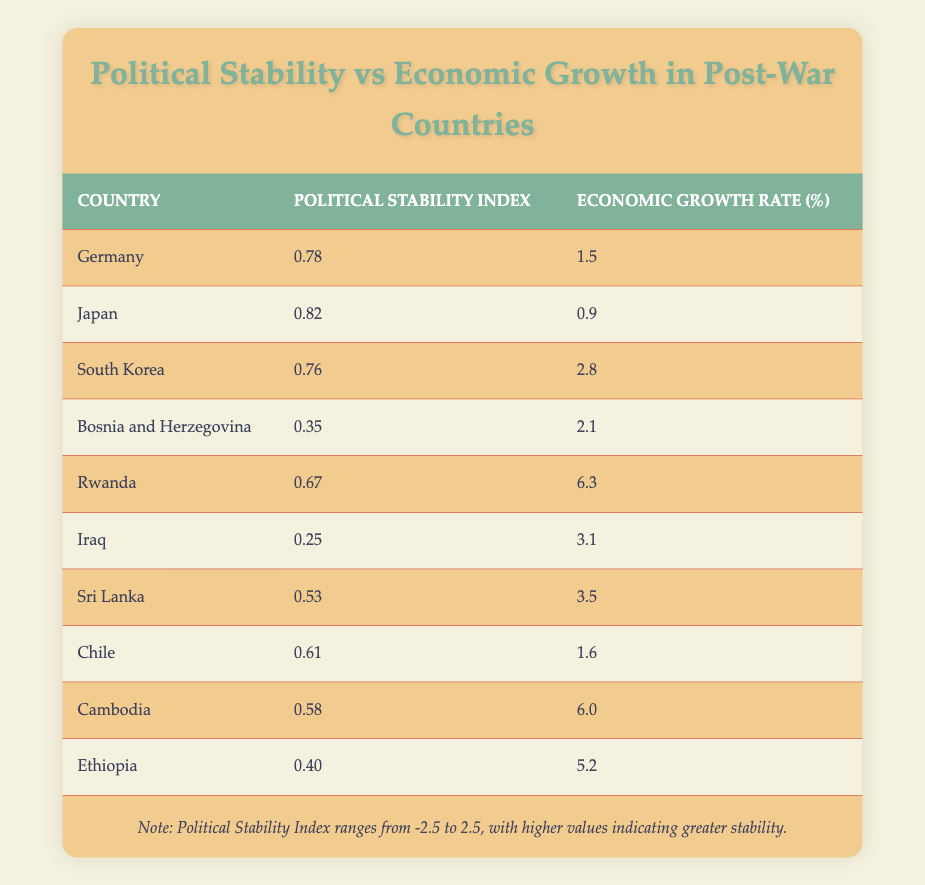What is the political stability index of Rwanda? The table shows that Rwanda has a political stability index of 0.67, which can be found in the corresponding row for Rwanda.
Answer: 0.67 Which country has the highest economic growth rate? By examining the economic growth rates in the table, Rwanda has the highest rate at 6.3%, which is greater than all other countries listed.
Answer: Rwanda What is the average political stability index of the countries listed? To calculate the average, add the political stability indices: (0.78 + 0.82 + 0.76 + 0.35 + 0.67 + 0.25 + 0.53 + 0.61 + 0.58 + 0.40) = 5.77. There are 10 countries, so the average is 5.77 / 10 = 0.577.
Answer: 0.577 Is Japan's political stability index greater than the average? Japan has a political stability index of 0.82. The average political stability index is 0.577. Since 0.82 is greater than 0.577, the statement is true.
Answer: Yes Which countries have an economic growth rate above 3%? Reviewing the table, the countries with an economic growth rate above 3% are South Korea (2.8%), Rwanda (6.3%), Iraq (3.1%), Sri Lanka (3.5%), Cambodia (6.0%), and Ethiopia (5.2%). Hence, the list includes South Korea, Rwanda, Iraq, Sri Lanka, Cambodia, and Ethiopia based on their growth rates indicated.
Answer: South Korea, Rwanda, Iraq, Sri Lanka, Cambodia, Ethiopia What is the difference in political stability indices between the highest and lowest countries? The highest stability index is 0.82 for Japan and the lowest is 0.25 for Iraq. The difference is calculated as 0.82 - 0.25 = 0.57.
Answer: 0.57 Which country has a political stability index below 0.5 and an economic growth rate above 3%? From the table, Iraq has a political stability index of 0.25 (below 0.5) and an economic growth rate of 3.1% (above 3%). Therefore, Iraq meets both criteria.
Answer: Iraq What proportion of the countries have political stability indices below 0.6? The countries with indices below 0.6 are Bosnia and Herzegovina (0.35), Iraq (0.25), and Ethiopia (0.40), totaling 3 countries. With 10 countries in total, the proportion is 3/10, which simplifies to 0.3 or 30%.
Answer: 30% What are the political stability indices of countries with economic growth rates above 5%? The countries with economic growth rates above 5% are Rwanda (6.3%) and Cambodia (6.0%). Therefore, their political stability indices are 0.67 for Rwanda and 0.58 for Cambodia.
Answer: 0.67, 0.58 